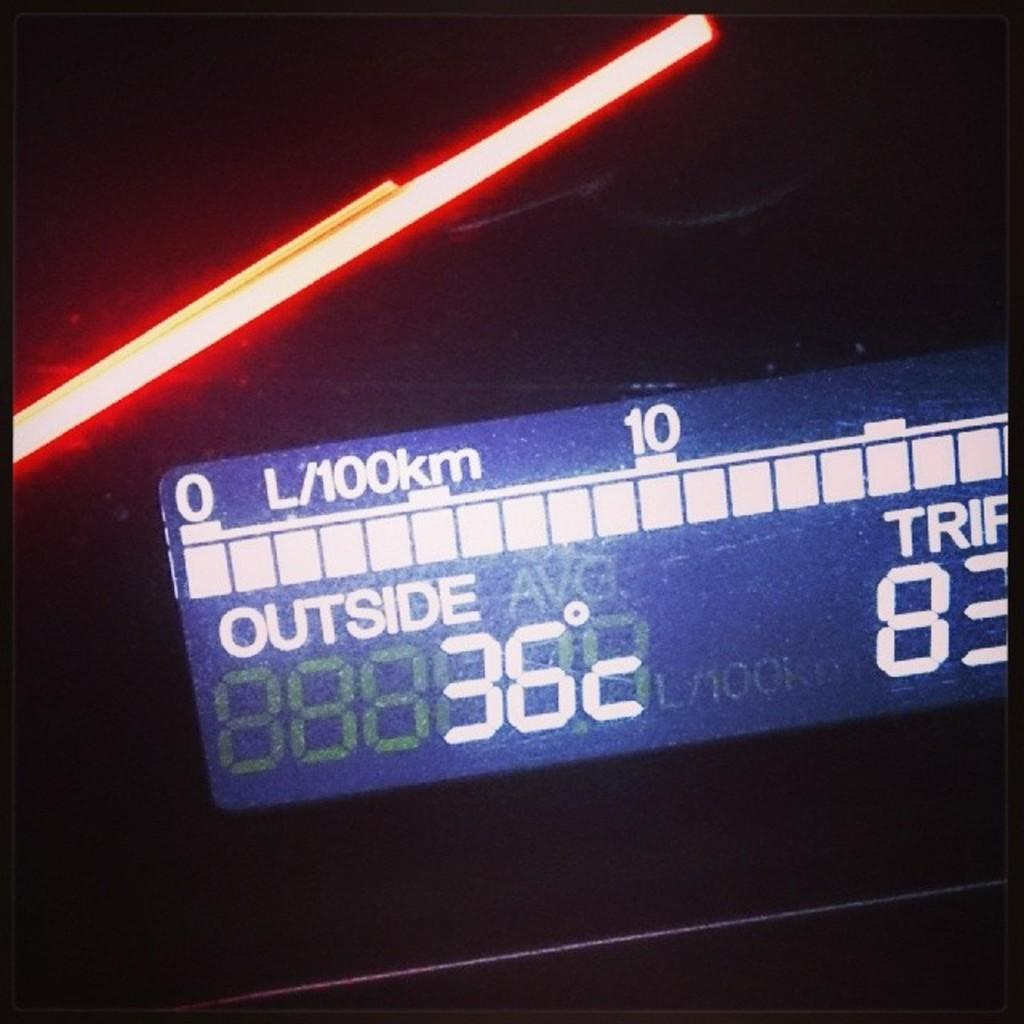<image>
Offer a succinct explanation of the picture presented. A digital display in a car dash cluster showing the outside temperature and trip distance. 